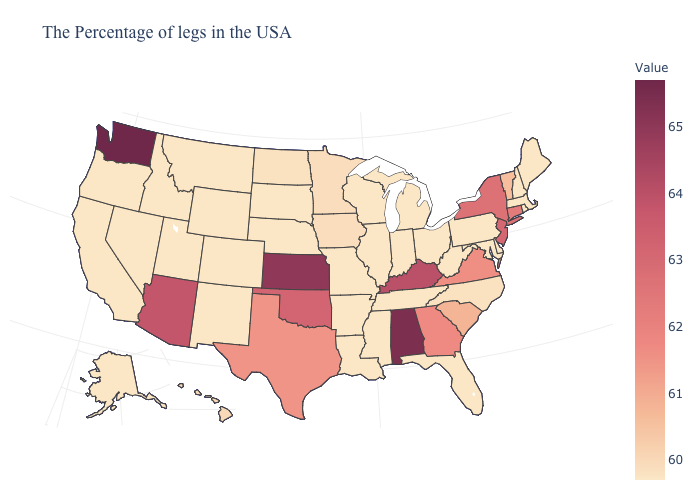Does the map have missing data?
Keep it brief. No. Which states have the lowest value in the USA?
Give a very brief answer. Maine, Massachusetts, Rhode Island, New Hampshire, Delaware, Maryland, Pennsylvania, West Virginia, Ohio, Florida, Michigan, Indiana, Tennessee, Wisconsin, Illinois, Mississippi, Louisiana, Missouri, Arkansas, Nebraska, South Dakota, Wyoming, Colorado, New Mexico, Utah, Montana, Idaho, Nevada, California, Oregon, Alaska. Does Arkansas have the lowest value in the USA?
Concise answer only. Yes. Does the map have missing data?
Keep it brief. No. Among the states that border West Virginia , which have the highest value?
Keep it brief. Kentucky. Does Washington have the highest value in the USA?
Write a very short answer. Yes. Does Florida have the lowest value in the USA?
Be succinct. Yes. Which states have the lowest value in the USA?
Be succinct. Maine, Massachusetts, Rhode Island, New Hampshire, Delaware, Maryland, Pennsylvania, West Virginia, Ohio, Florida, Michigan, Indiana, Tennessee, Wisconsin, Illinois, Mississippi, Louisiana, Missouri, Arkansas, Nebraska, South Dakota, Wyoming, Colorado, New Mexico, Utah, Montana, Idaho, Nevada, California, Oregon, Alaska. 